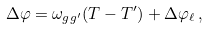Convert formula to latex. <formula><loc_0><loc_0><loc_500><loc_500>\Delta \varphi = \omega _ { g g ^ { \prime } } ( T - T ^ { \prime } ) + \Delta \varphi _ { \ell } \, ,</formula> 